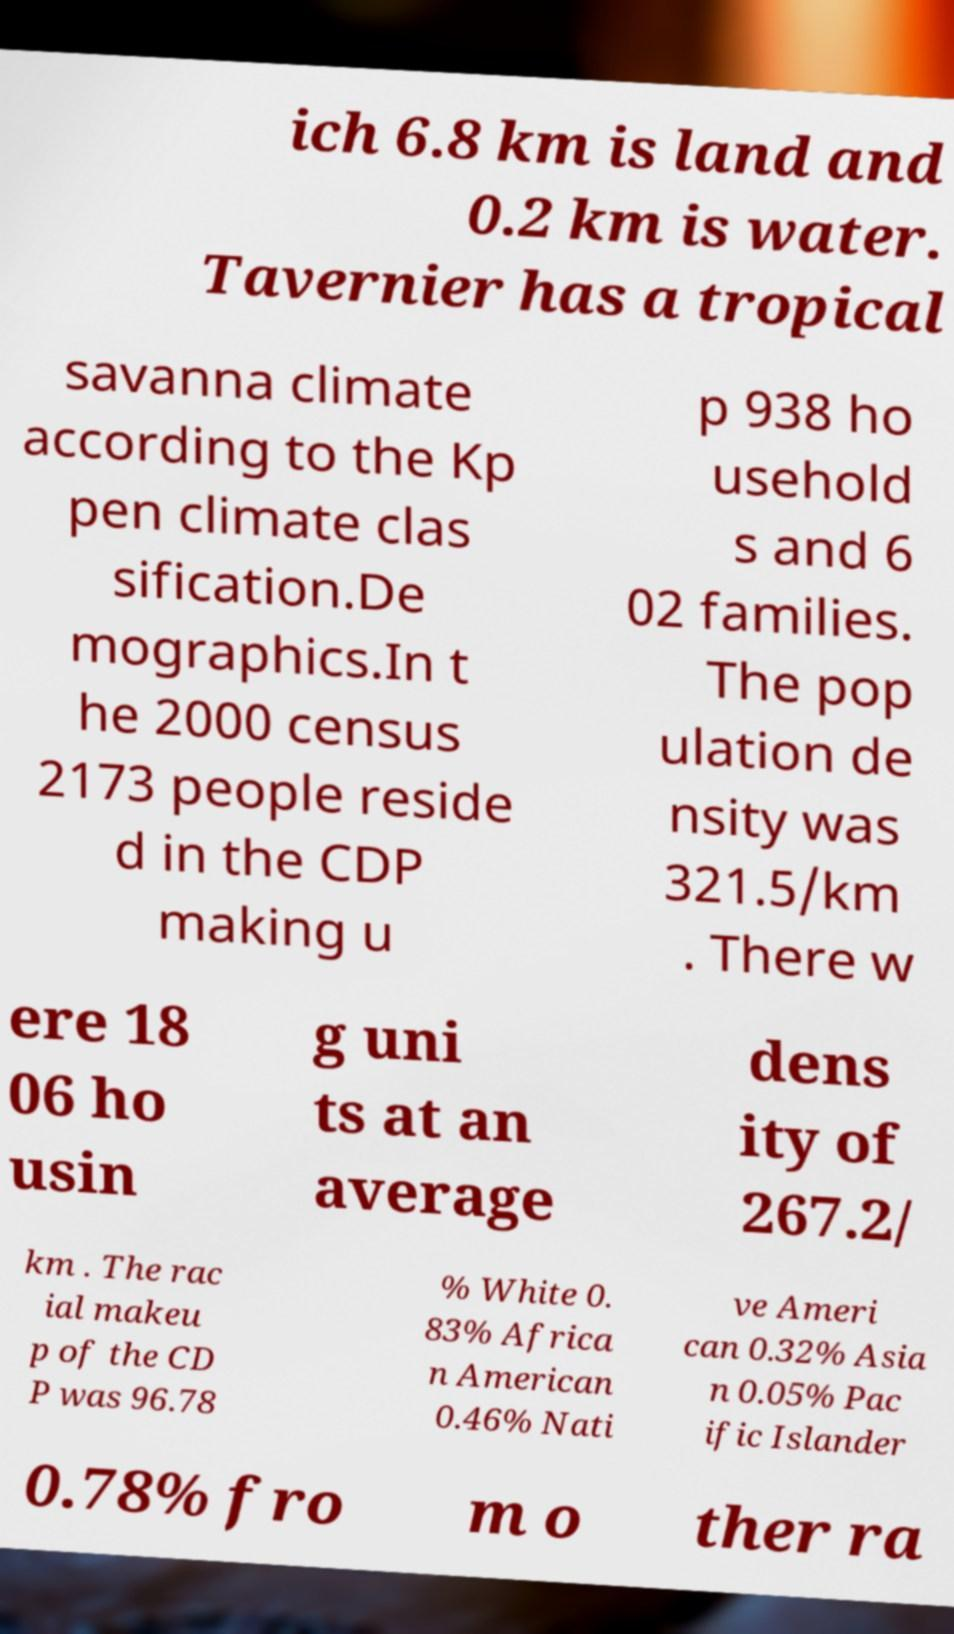What messages or text are displayed in this image? I need them in a readable, typed format. ich 6.8 km is land and 0.2 km is water. Tavernier has a tropical savanna climate according to the Kp pen climate clas sification.De mographics.In t he 2000 census 2173 people reside d in the CDP making u p 938 ho usehold s and 6 02 families. The pop ulation de nsity was 321.5/km . There w ere 18 06 ho usin g uni ts at an average dens ity of 267.2/ km . The rac ial makeu p of the CD P was 96.78 % White 0. 83% Africa n American 0.46% Nati ve Ameri can 0.32% Asia n 0.05% Pac ific Islander 0.78% fro m o ther ra 